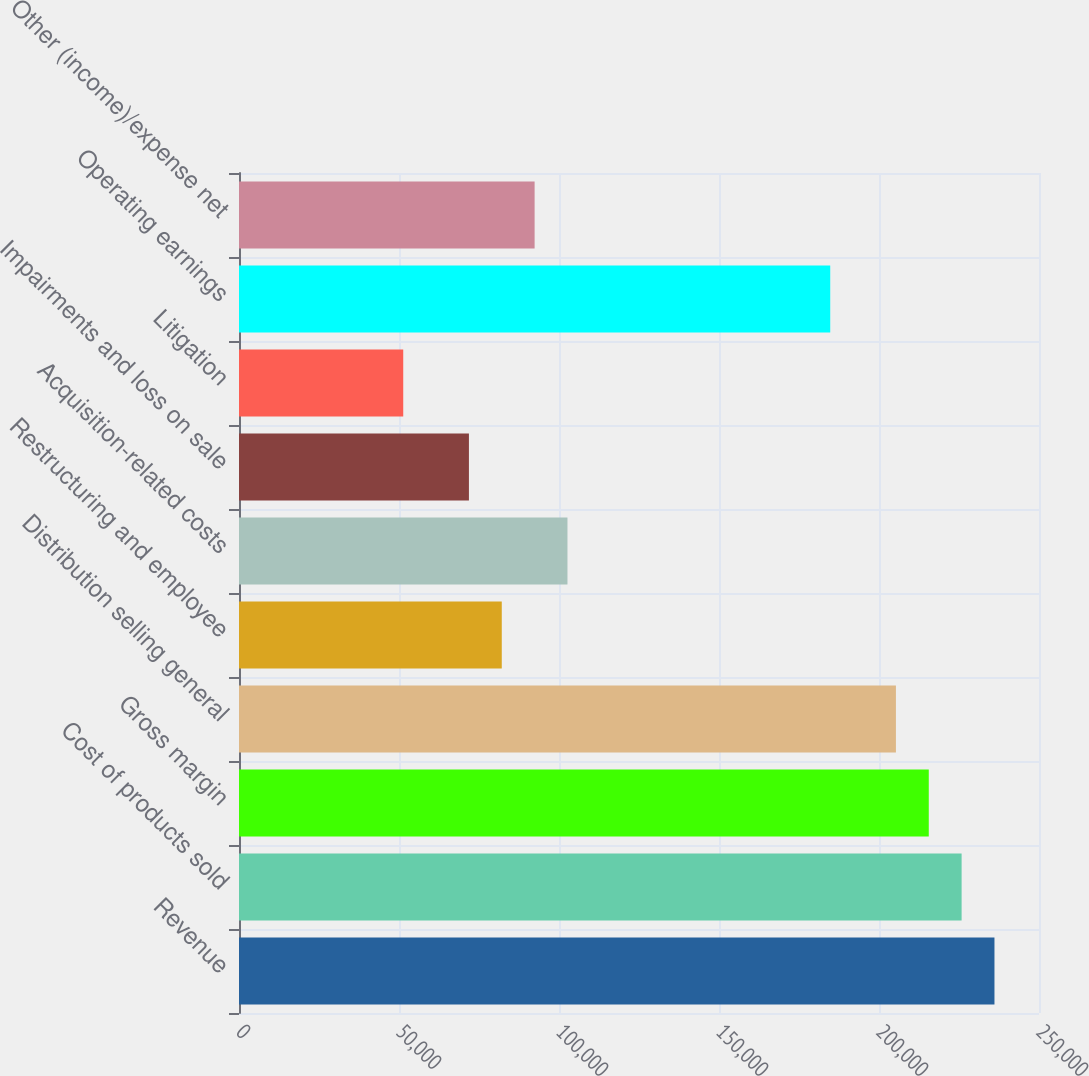<chart> <loc_0><loc_0><loc_500><loc_500><bar_chart><fcel>Revenue<fcel>Cost of products sold<fcel>Gross margin<fcel>Distribution selling general<fcel>Restructuring and employee<fcel>Acquisition-related costs<fcel>Impairments and loss on sale<fcel>Litigation<fcel>Operating earnings<fcel>Other (income)/expense net<nl><fcel>236082<fcel>225817<fcel>215553<fcel>205288<fcel>82115.4<fcel>102644<fcel>71851<fcel>51322.1<fcel>184760<fcel>92379.8<nl></chart> 